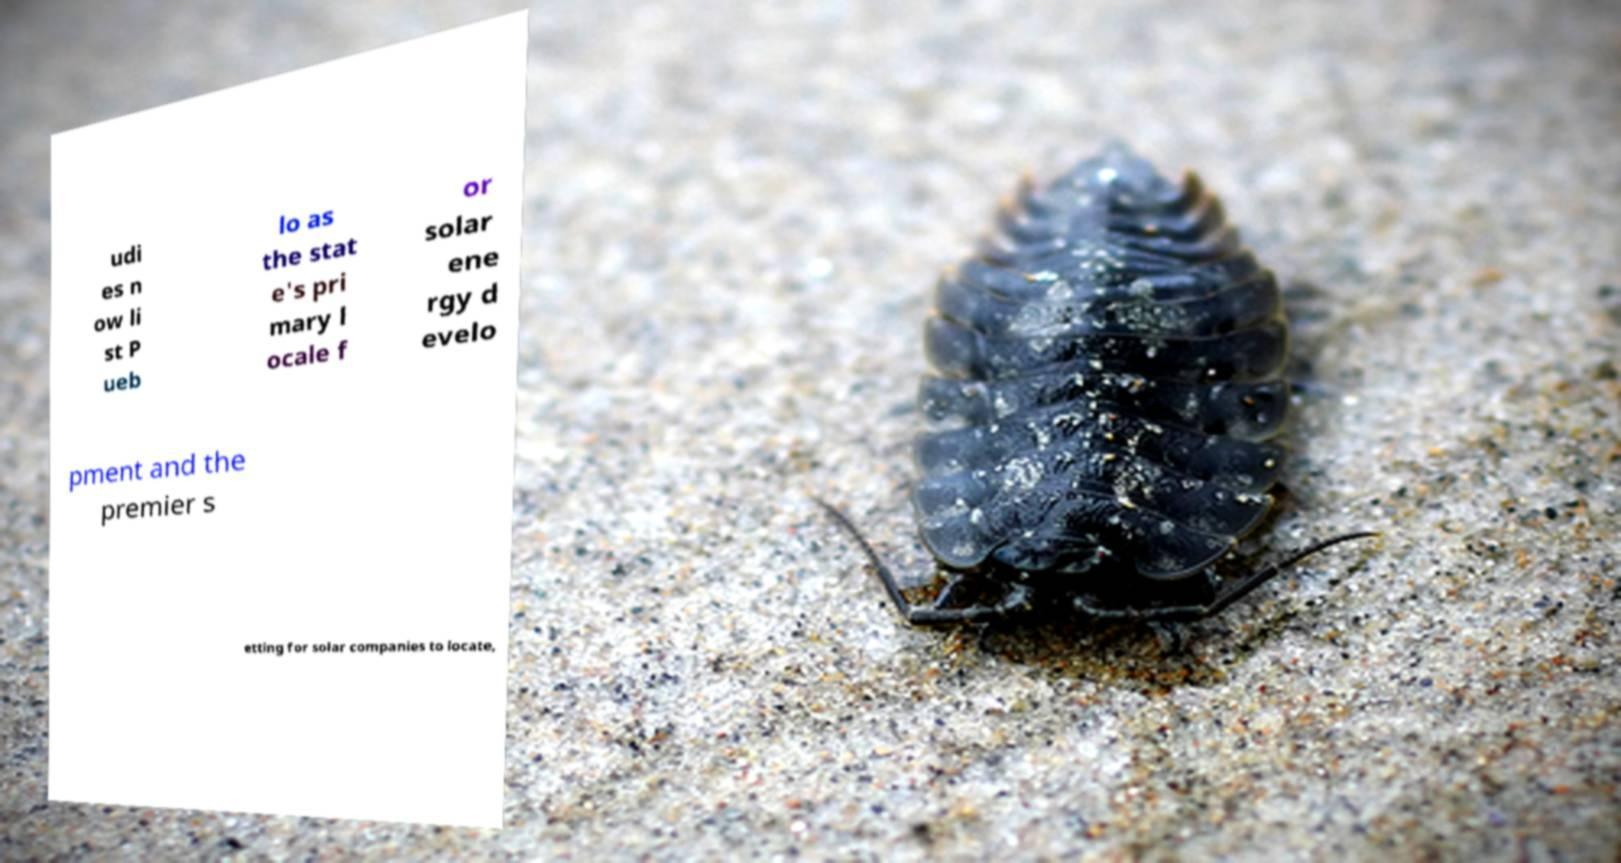For documentation purposes, I need the text within this image transcribed. Could you provide that? udi es n ow li st P ueb lo as the stat e's pri mary l ocale f or solar ene rgy d evelo pment and the premier s etting for solar companies to locate, 